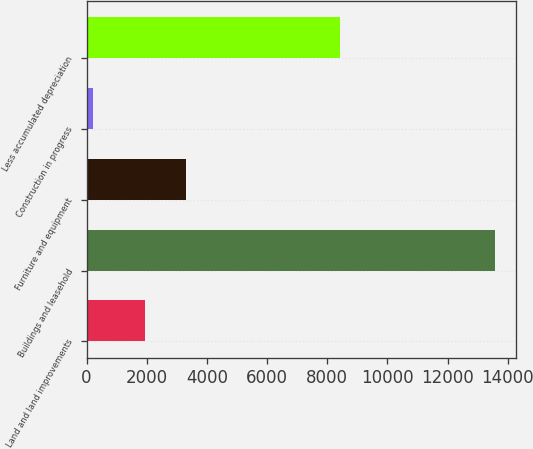Convert chart to OTSL. <chart><loc_0><loc_0><loc_500><loc_500><bar_chart><fcel>Land and land improvements<fcel>Buildings and leasehold<fcel>Furniture and equipment<fcel>Construction in progress<fcel>Less accumulated depreciation<nl><fcel>1960<fcel>13586<fcel>3296.6<fcel>220<fcel>8417<nl></chart> 